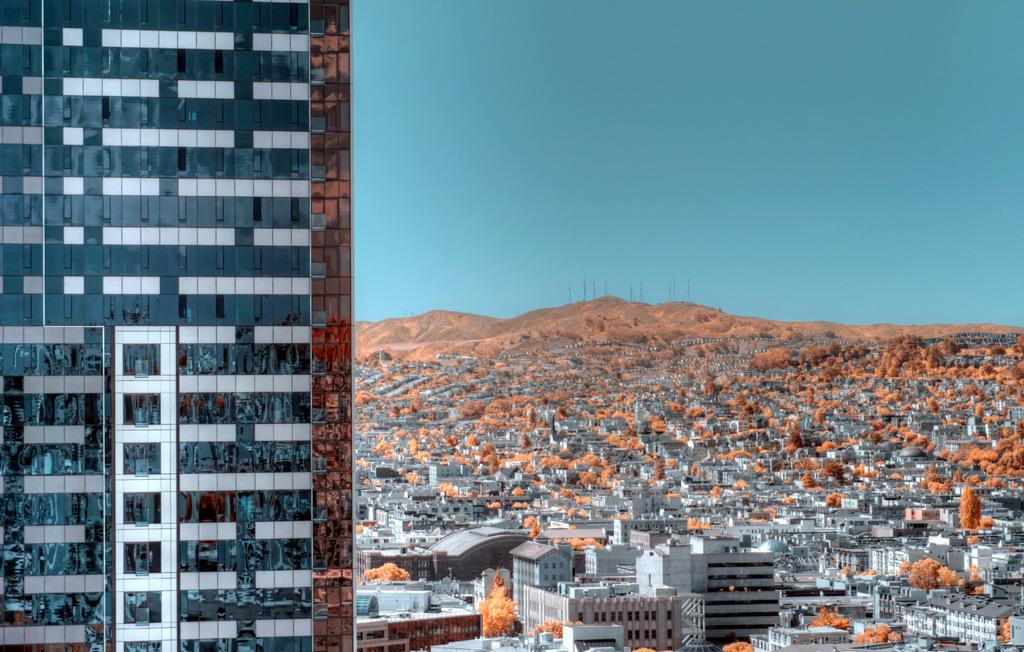What type of building is located on the left side of the image? There is a glass building on the left side of the image. What can be seen in the background of the image? There are buildings, trees, and mountains visible in the background of the image. What is the color of the sky in the image? The sky is blue in the image. What type of appliance can be seen on the ground near the trees in the image? There is no appliance visible on the ground near the trees in the image. How many rocks are present in the image? There is no mention of rocks in the image, so it is impossible to determine how many are present. 